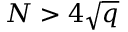Convert formula to latex. <formula><loc_0><loc_0><loc_500><loc_500>N > 4 { \sqrt { q } }</formula> 